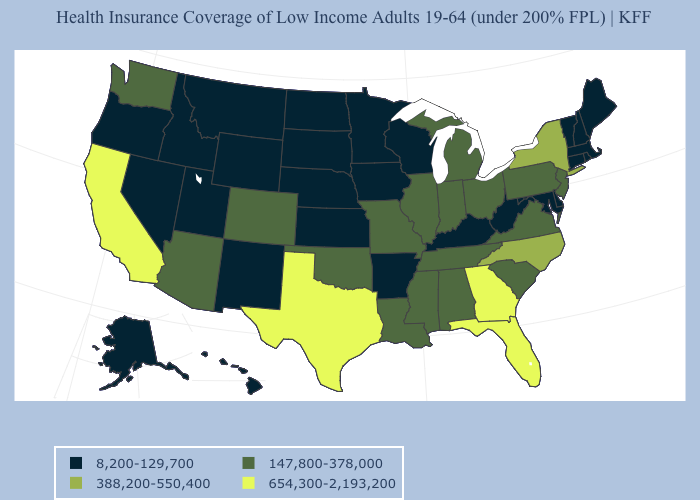What is the value of Nebraska?
Give a very brief answer. 8,200-129,700. Which states hav the highest value in the West?
Write a very short answer. California. What is the value of Vermont?
Give a very brief answer. 8,200-129,700. Does Arizona have a lower value than Delaware?
Write a very short answer. No. What is the highest value in states that border Minnesota?
Answer briefly. 8,200-129,700. Name the states that have a value in the range 654,300-2,193,200?
Keep it brief. California, Florida, Georgia, Texas. What is the lowest value in states that border Missouri?
Keep it brief. 8,200-129,700. What is the lowest value in the South?
Concise answer only. 8,200-129,700. Does the map have missing data?
Be succinct. No. What is the value of Alabama?
Keep it brief. 147,800-378,000. Name the states that have a value in the range 8,200-129,700?
Quick response, please. Alaska, Arkansas, Connecticut, Delaware, Hawaii, Idaho, Iowa, Kansas, Kentucky, Maine, Maryland, Massachusetts, Minnesota, Montana, Nebraska, Nevada, New Hampshire, New Mexico, North Dakota, Oregon, Rhode Island, South Dakota, Utah, Vermont, West Virginia, Wisconsin, Wyoming. What is the lowest value in states that border Wyoming?
Be succinct. 8,200-129,700. What is the lowest value in states that border Washington?
Short answer required. 8,200-129,700. Among the states that border Iowa , which have the highest value?
Keep it brief. Illinois, Missouri. Which states have the lowest value in the MidWest?
Write a very short answer. Iowa, Kansas, Minnesota, Nebraska, North Dakota, South Dakota, Wisconsin. 